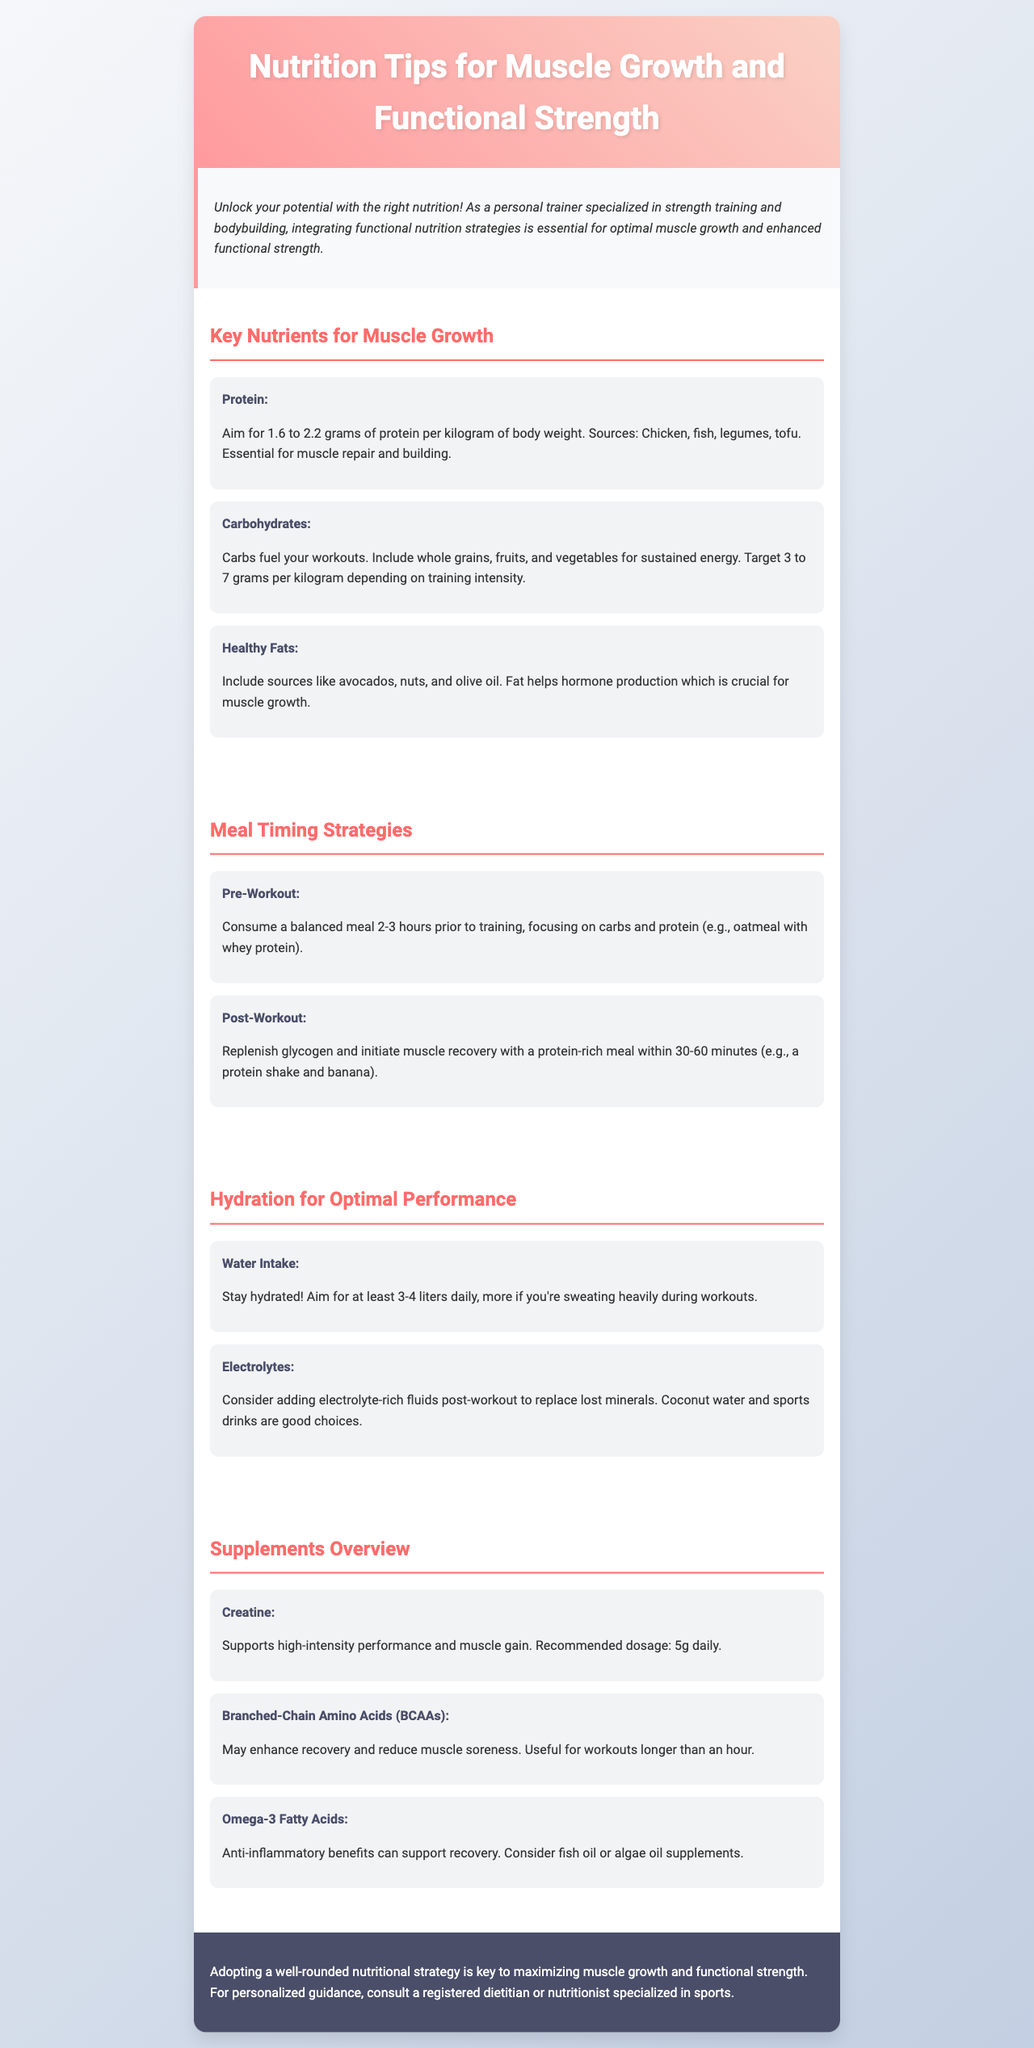What is the recommended protein intake per kilogram of body weight? The document states to aim for 1.6 to 2.2 grams of protein per kilogram of body weight for muscle growth.
Answer: 1.6 to 2.2 grams What foods are recommended for carbohydrates? The brochure suggests including whole grains, fruits, and vegetables as sources of carbohydrates.
Answer: Whole grains, fruits, and vegetables What is the recommended water intake daily? The document advises aiming for at least 3-4 liters of water daily for optimal hydration.
Answer: 3-4 liters What supplement dosage is recommended for creatine? The document specifies a recommended dosage of 5 grams daily for creatine supplementation.
Answer: 5g daily Why are healthy fats important? The brochure explains that healthy fats help hormone production, which is crucial for muscle growth.
Answer: Hormone production What should be consumed within 30-60 minutes post-workout? The document recommends a protein-rich meal within 30-60 minutes post-workout to aid recovery.
Answer: Protein-rich meal What is a good pre-workout meal suggestion mentioned? The brochure suggests consuming a balanced meal 2-3 hours prior to training, focusing on carbs and protein, such as oatmeal with whey protein.
Answer: Oatmeal with whey protein What are BCAAs used for according to the document? The brochure states that BCAAs may enhance recovery and reduce muscle soreness, especially in workouts longer than an hour.
Answer: Enhance recovery and reduce soreness 